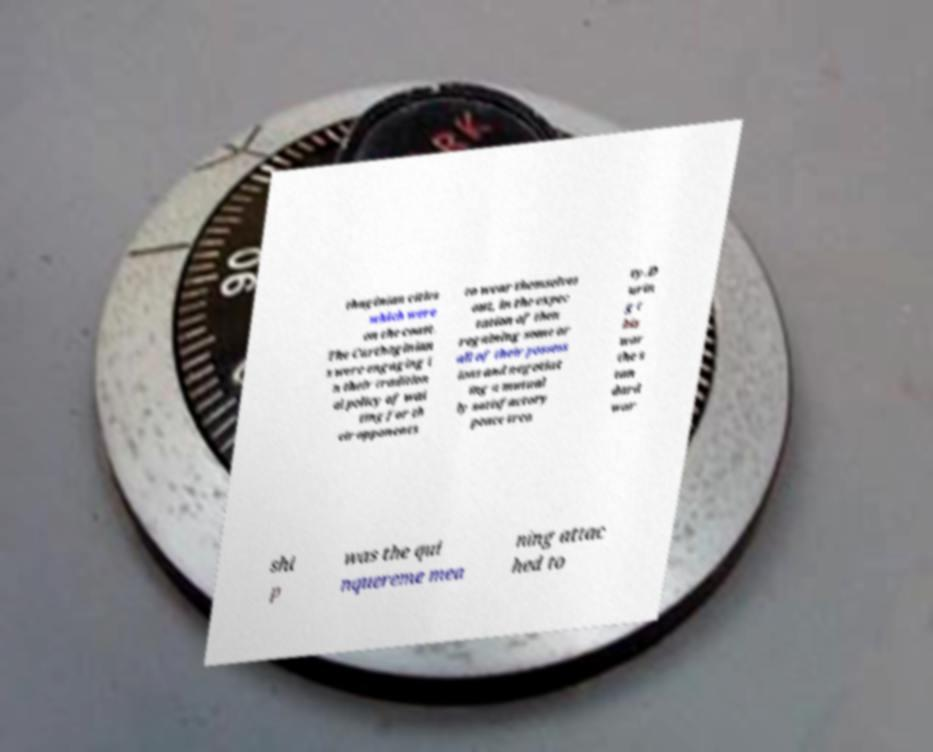Could you assist in decoding the text presented in this image and type it out clearly? thaginian cities which were on the coast. The Carthaginian s were engaging i n their tradition al policy of wai ting for th eir opponents to wear themselves out, in the expec tation of then regaining some or all of their possess ions and negotiat ing a mutual ly satisfactory peace trea ty.D urin g t his war the s tan dard war shi p was the qui nquereme mea ning attac hed to 